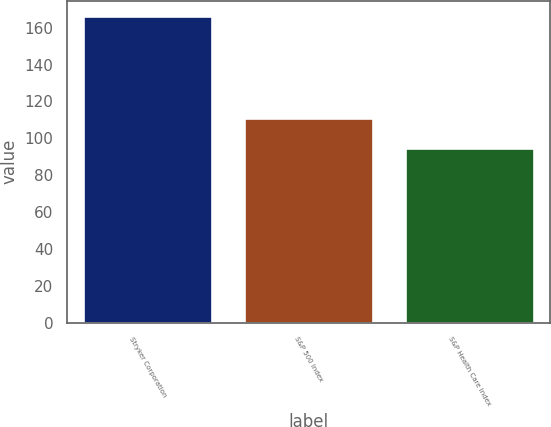Convert chart to OTSL. <chart><loc_0><loc_0><loc_500><loc_500><bar_chart><fcel>Stryker Corporation<fcel>S&P 500 Index<fcel>S&P Health Care Index<nl><fcel>166.2<fcel>111.15<fcel>94.96<nl></chart> 